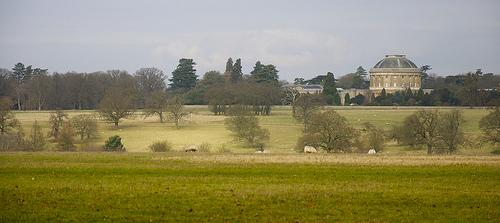What kind of building is in the image and what is its color? The building is an observatory with a dome roof and it is brown in color. What is the purpose of the building in the image, and describe its appearance. The building appears to be an observatory with a dome roof and a gray-colored flat structure on top, used for observations. Identify the primary focus of this image. The primary focus of the image is the outdoor scene featuring trees, grass, a building, and grazing animals in a field. What is the weather like in the image, and describe the sky. It is a sunny clear day with white and gray clouds in the blue sky. What activity are the animals engaged in within the image? The animals are grazing on grass, with cows and a goat eating grass for survival. Provide an overall sentiment and mention the quality of the image capture. The image sentiment is positive as it's a lovely outdoor scene captured in a nice shot on a sunny day. Perform a VQA task for the image: What is on the top of the roof of the round building? A flat structure is on the top of the roof of the round building. How many animals can be identified in the image? List those animals. Four animals can be identified: white cows, sheep, a goat, and white clouds. What type of trees can be found in the image, and what state are they in? There are both deciduous trees that have lost their leaves and evergreen pine trees in the image, some being in a dry state. What time of the day the scene takes place? Daytime Please create a short story that connects the field with grazing animals to the observatory building. Once upon a time, in a peaceful countryside, the observatory building overlooked the grazing animals in the lush green field, where they would feed and play under the watchful eyes of both the scientists and the evergreen trees nearby. What activity are the animals engaging in within the image? Grazing on grass Please provide a detailed description of the building in the image. Large white, brown brick building with an archway entrance, round observatory-looking structure, gray dome roof, flat structure on top, surrounded by evergreen pine trees What color is the grass in the scene? Green What color is the roof of the building in the image? Gray Is it a sunny day in the image? Yes Please caption this outdoor scene, mentioning the type of trees and the weather. A sunny day outdoors with evergreen and deciduous trees, white clouds, and a blue sky Choose the correct description of the trees in the image: A) Evergreen B) Deciduous C) Dry D) All the above D) All the above What type of outdoor location is depicted in the image? A field with grazing animals, trees, and a building What color is the sky in the image? Blue Which of the following animals is depicted in the image? A) Cows B) Sheep C) Goats D) None A) Cows B) Sheep Describe the presence of clouds in the sky. White clouds in the blue sky, some areas covered by clouds What is the purpose of the building in the image? A round observatory looking building State any text visible in the image. No text visible Can you describe the style of the building in the image? Round observatory-looking building with a gray dome roof and a flat structure on top Describe the vegetation found in the scene. Green grass on the ground, long green trees in the forest, small green tree with bushes 